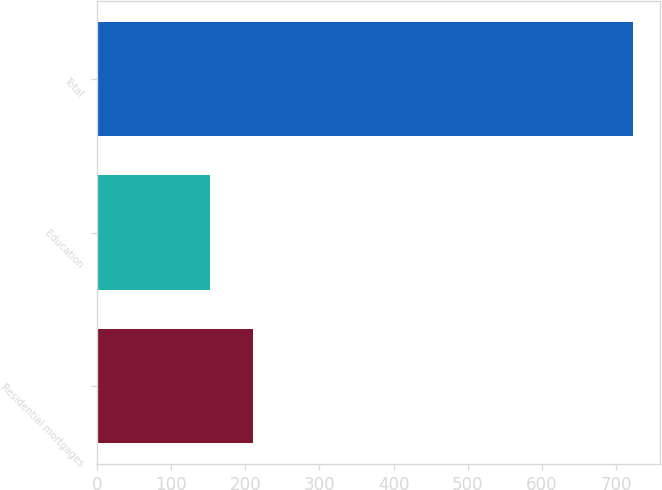Convert chart to OTSL. <chart><loc_0><loc_0><loc_500><loc_500><bar_chart><fcel>Residential mortgages<fcel>Education<fcel>Total<nl><fcel>210<fcel>153<fcel>723<nl></chart> 